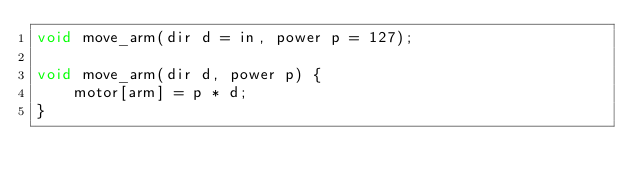<code> <loc_0><loc_0><loc_500><loc_500><_C_>void move_arm(dir d = in, power p = 127);

void move_arm(dir d, power p) {
    motor[arm] = p * d;
}
</code> 